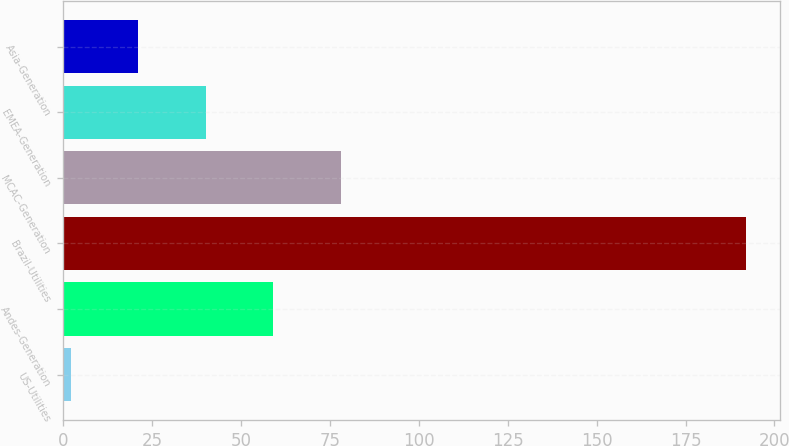Convert chart. <chart><loc_0><loc_0><loc_500><loc_500><bar_chart><fcel>US-Utilities<fcel>Andes-Generation<fcel>Brazil-Utilities<fcel>MCAC-Generation<fcel>EMEA-Generation<fcel>Asia-Generation<nl><fcel>2<fcel>59<fcel>192<fcel>78<fcel>40<fcel>21<nl></chart> 